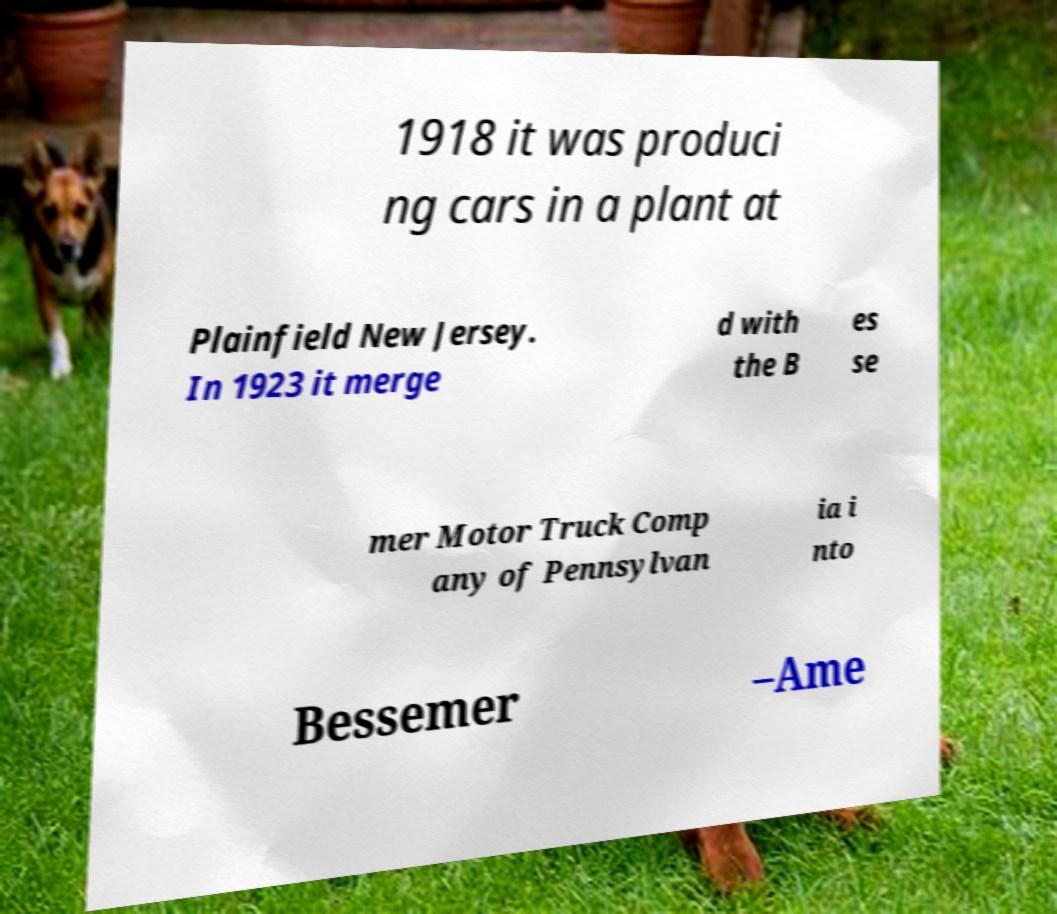I need the written content from this picture converted into text. Can you do that? 1918 it was produci ng cars in a plant at Plainfield New Jersey. In 1923 it merge d with the B es se mer Motor Truck Comp any of Pennsylvan ia i nto Bessemer –Ame 